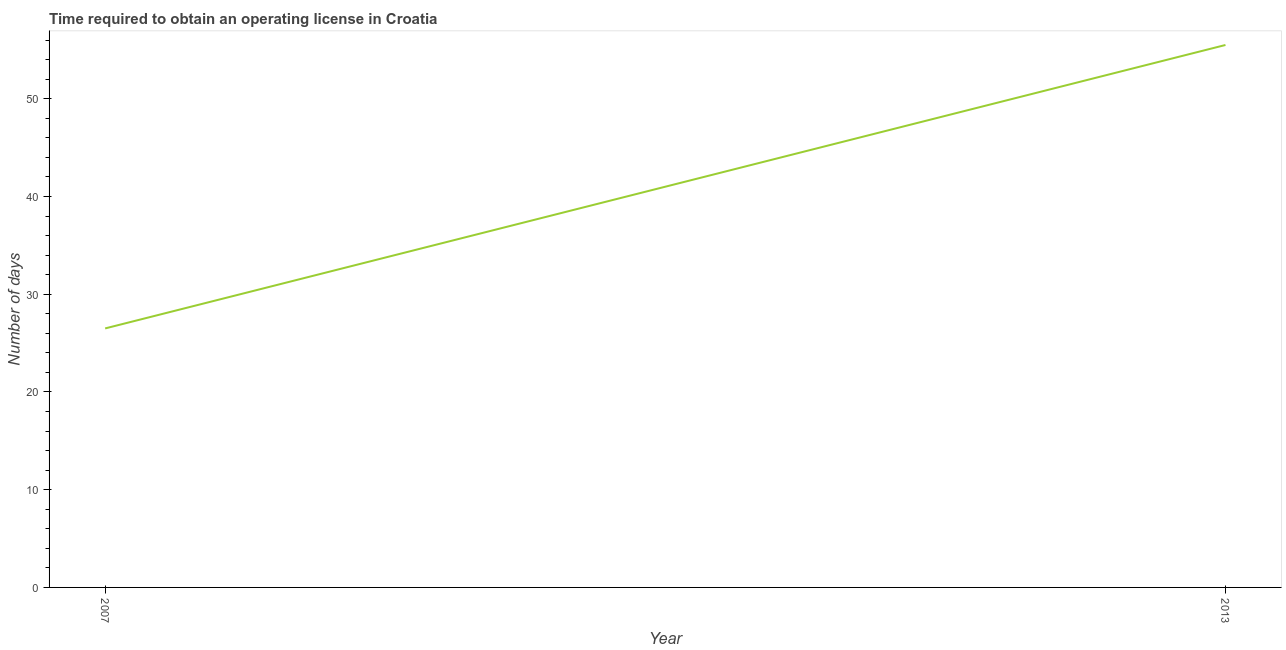What is the number of days to obtain operating license in 2007?
Your response must be concise. 26.5. Across all years, what is the maximum number of days to obtain operating license?
Offer a very short reply. 55.5. In which year was the number of days to obtain operating license maximum?
Your response must be concise. 2013. In how many years, is the number of days to obtain operating license greater than 34 days?
Your response must be concise. 1. Do a majority of the years between 2013 and 2007 (inclusive) have number of days to obtain operating license greater than 52 days?
Give a very brief answer. No. What is the ratio of the number of days to obtain operating license in 2007 to that in 2013?
Keep it short and to the point. 0.48. Is the number of days to obtain operating license in 2007 less than that in 2013?
Give a very brief answer. Yes. Does the number of days to obtain operating license monotonically increase over the years?
Give a very brief answer. Yes. How many lines are there?
Make the answer very short. 1. What is the difference between two consecutive major ticks on the Y-axis?
Offer a terse response. 10. Are the values on the major ticks of Y-axis written in scientific E-notation?
Keep it short and to the point. No. Does the graph contain grids?
Offer a terse response. No. What is the title of the graph?
Keep it short and to the point. Time required to obtain an operating license in Croatia. What is the label or title of the Y-axis?
Your response must be concise. Number of days. What is the Number of days in 2007?
Your response must be concise. 26.5. What is the Number of days in 2013?
Your response must be concise. 55.5. What is the difference between the Number of days in 2007 and 2013?
Keep it short and to the point. -29. What is the ratio of the Number of days in 2007 to that in 2013?
Your response must be concise. 0.48. 